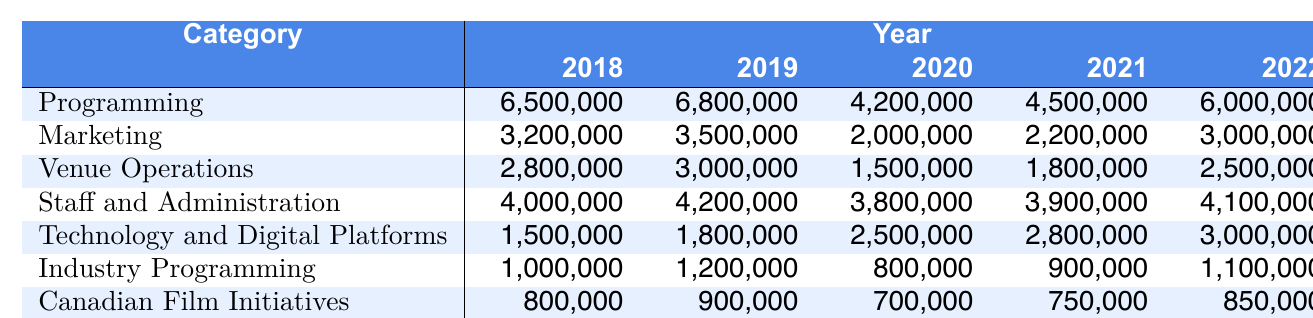What was the budget allocation for Programming in 2020? The table lists the budget allocation for Programming in 2020 as 4,200,000.
Answer: 4,200,000 Which category experienced the largest budget cut from 2019 to 2020? The largest cut occurred in Programming, where the budget decreased from 6,800,000 in 2019 to 4,200,000 in 2020, a total reduction of 2,600,000.
Answer: Programming What is the total budget allocation for Marketing from 2018 to 2022? The total allocation is calculated by adding the yearly values: 3,200,000 + 3,500,000 + 2,000,000 + 2,200,000 + 3,000,000 = 13,900,000.
Answer: 13,900,000 Did the budget for Staff and Administration increase every year from 2018 to 2022? No, the budget for Staff and Administration decreased from 4,200,000 in 2019 to 3,800,000 in 2020.
Answer: No What is the average budget allocation for Technology and Digital Platforms from 2018 to 2022? The average is calculated by summing the values (1,500,000 + 1,800,000 + 2,500,000 + 2,800,000 + 3,000,000 = 11,600,000) and then dividing by 5, resulting in an average of 2,320,000.
Answer: 2,320,000 Which category had the highest budget allocation in 2022? In 2022, the category with the highest allocation is Programming, with 6,000,000.
Answer: Programming What is the difference in budget allocation for Venue Operations between 2018 and 2022? The difference is calculated as 2,500,000 (2022) - 2,800,000 (2018) = -300,000. This represents a decrease of 300,000.
Answer: 300,000 decrease Summarize the trend for Canadian Film Initiatives over the years. The budget allocation for Canadian Film Initiatives increased from 800,000 in 2018 to 850,000 in 2022, showing a slight upward trend overall, with a decrease in 2020 and stable allocations in 2021.
Answer: Slight upward trend What was the total budget allocated to TIFF Bell Lightbox Operations over the five years? The total is calculated by adding each year: 2,200,000 + 2,400,000 + 1,200,000 + 1,500,000 + 2,000,000 = 9,300,000.
Answer: 9,300,000 In which year was the budget for Industry Programming the lowest? The budget for Industry Programming was lowest in 2020 at 800,000.
Answer: 2020 